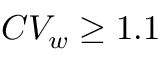Convert formula to latex. <formula><loc_0><loc_0><loc_500><loc_500>C V _ { w } \geq 1 . 1</formula> 